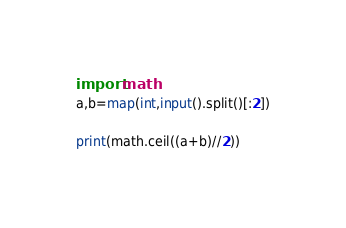Convert code to text. <code><loc_0><loc_0><loc_500><loc_500><_Python_>import math
a,b=map(int,input().split()[:2])

print(math.ceil((a+b)//2))</code> 